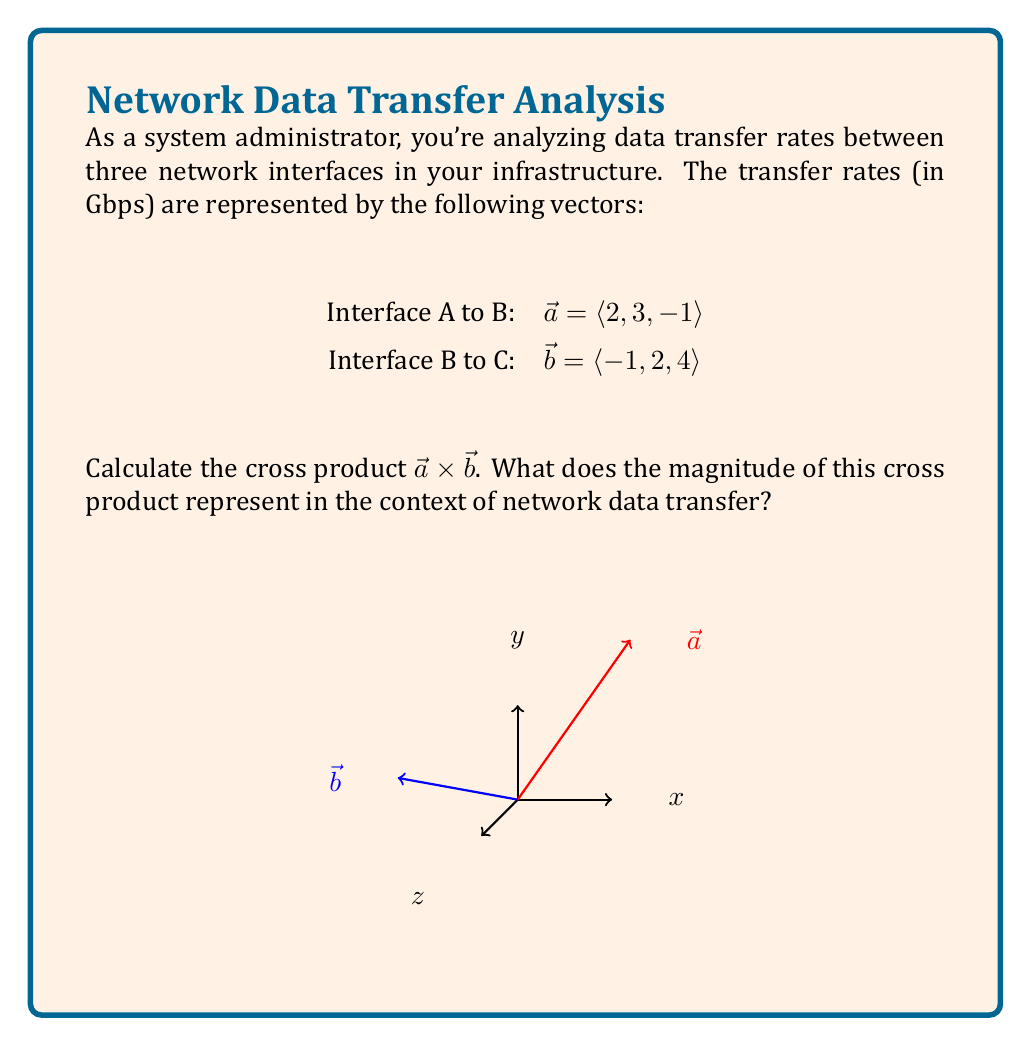Show me your answer to this math problem. Let's solve this step-by-step:

1) The cross product of two vectors $\vec{a} = \langle a_1, a_2, a_3 \rangle$ and $\vec{b} = \langle b_1, b_2, b_3 \rangle$ is defined as:

   $$\vec{a} \times \vec{b} = \langle a_2b_3 - a_3b_2, a_3b_1 - a_1b_3, a_1b_2 - a_2b_1 \rangle$$

2) In our case:
   $\vec{a} = \langle 2, 3, -1 \rangle$
   $\vec{b} = \langle -1, 2, 4 \rangle$

3) Let's calculate each component:
   
   First component: $a_2b_3 - a_3b_2 = (3)(4) - (-1)(2) = 12 + 2 = 14$
   
   Second component: $a_3b_1 - a_1b_3 = (-1)(-1) - (2)(4) = 1 - 8 = -7$
   
   Third component: $a_1b_2 - a_2b_1 = (2)(2) - (3)(-1) = 4 + 3 = 7$

4) Therefore, $\vec{a} \times \vec{b} = \langle 14, -7, 7 \rangle$

5) The magnitude of this cross product can be calculated as:

   $$|\vec{a} \times \vec{b}| = \sqrt{14^2 + (-7)^2 + 7^2} = \sqrt{196 + 49 + 49} = \sqrt{294} \approx 17.15$$

6) In the context of network data transfer, the magnitude of the cross product represents the area of the parallelogram formed by the two vectors. This can be interpreted as a measure of the "difference" or "independence" between the two data transfer rates. A larger magnitude indicates that the transfer rates are more dissimilar or independent.
Answer: $\vec{a} \times \vec{b} = \langle 14, -7, 7 \rangle$; magnitude ≈ 17.15 Gbps² 